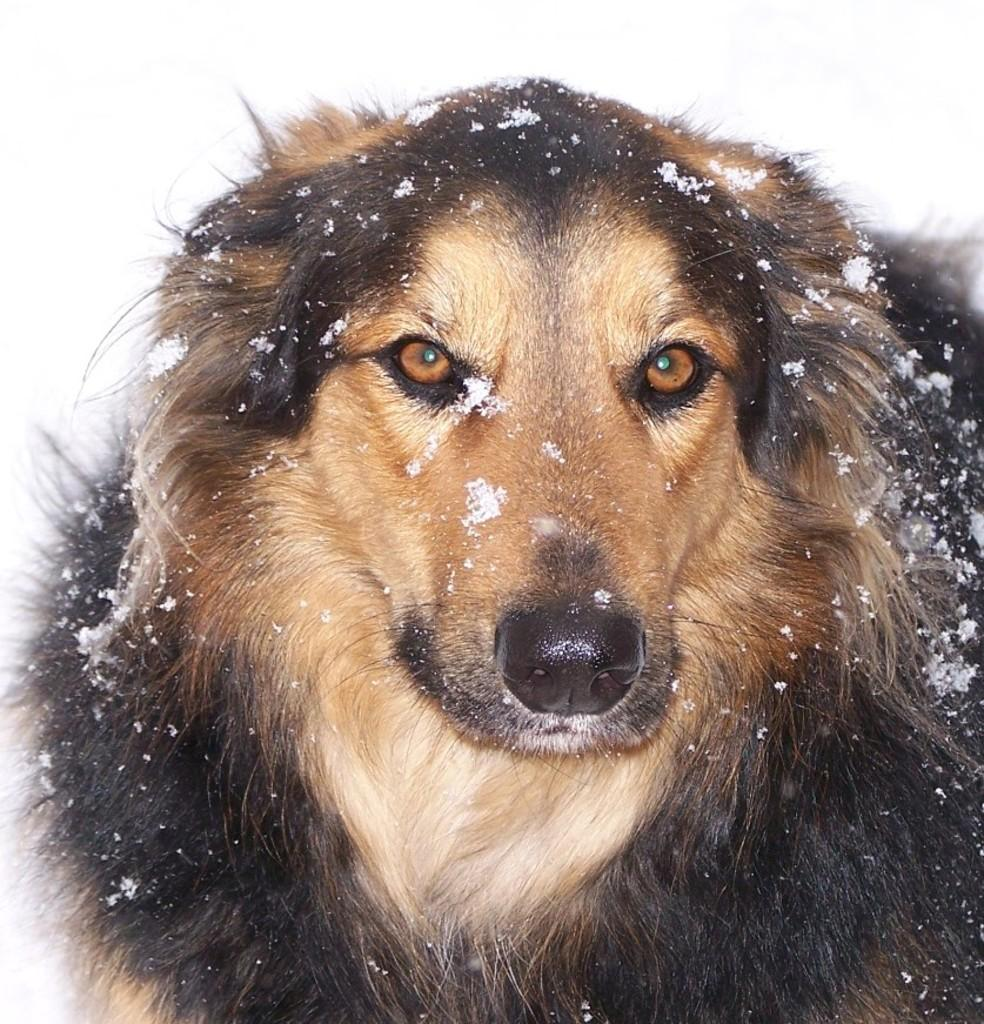What type of animal is in the image? There is a dog in the image. Can you describe the dog's coloring? The dog has brown and black coloring. What is the weather or environment like in the image? There is snow on the dog, which suggests a cold or snowy environment. What type of paper is the dog holding in the image? There is no paper present in the image; the dog is covered in snow. 